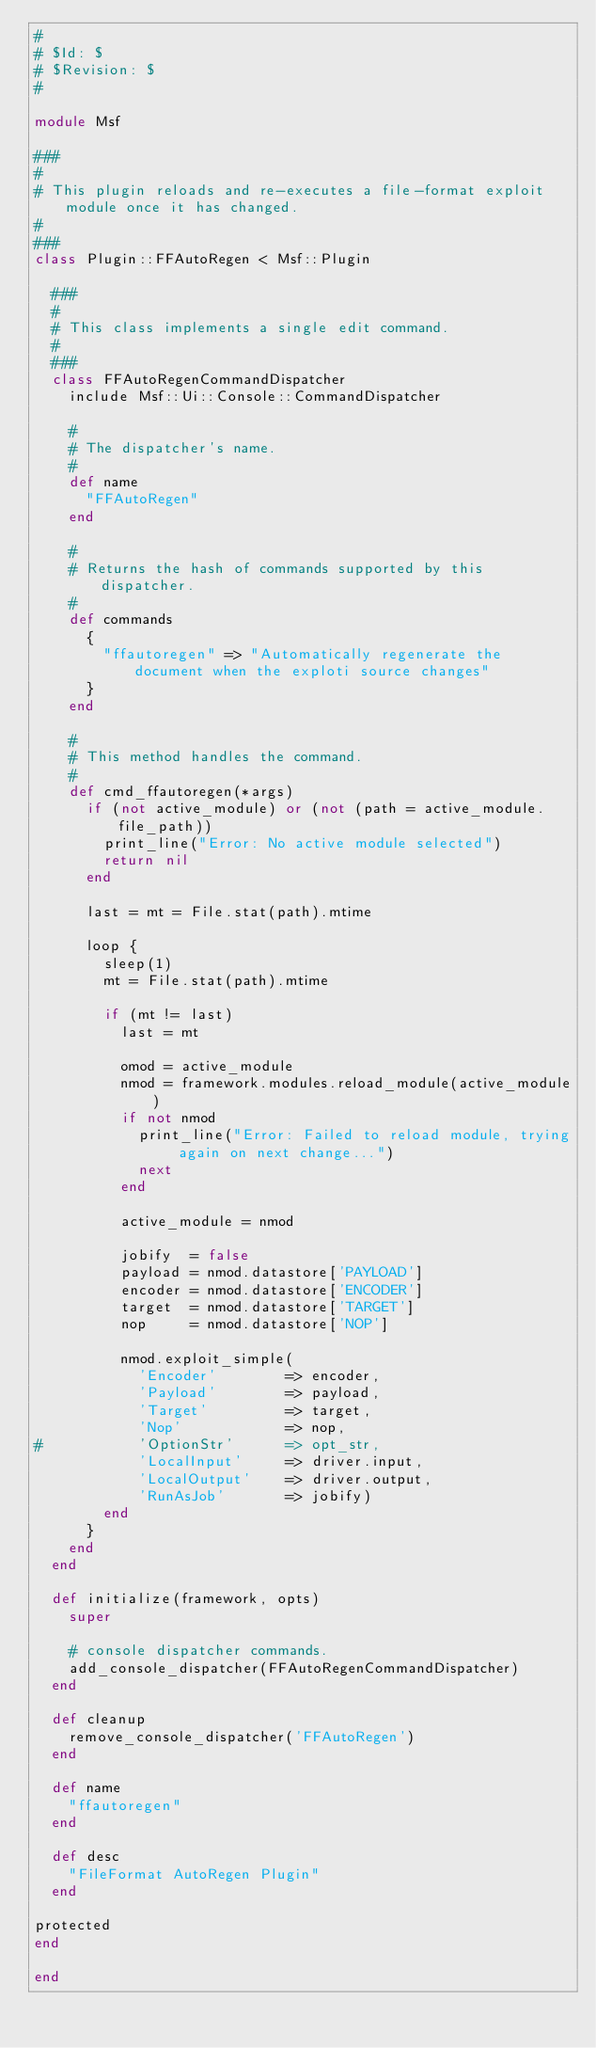Convert code to text. <code><loc_0><loc_0><loc_500><loc_500><_Ruby_>#
# $Id: $
# $Revision: $
#

module Msf

###
#
# This plugin reloads and re-executes a file-format exploit module once it has changed.
#
###
class Plugin::FFAutoRegen < Msf::Plugin

  ###
  #
  # This class implements a single edit command.
  #
  ###
  class FFAutoRegenCommandDispatcher
    include Msf::Ui::Console::CommandDispatcher

    #
    # The dispatcher's name.
    #
    def name
      "FFAutoRegen"
    end

    #
    # Returns the hash of commands supported by this dispatcher.
    #
    def commands
      {
        "ffautoregen" => "Automatically regenerate the document when the exploti source changes"
      }
    end

    #
    # This method handles the command.
    #
    def cmd_ffautoregen(*args)
      if (not active_module) or (not (path = active_module.file_path))
        print_line("Error: No active module selected")
        return nil
      end

      last = mt = File.stat(path).mtime

      loop {
        sleep(1)
        mt = File.stat(path).mtime

        if (mt != last)
          last = mt

          omod = active_module
          nmod = framework.modules.reload_module(active_module)
          if not nmod
            print_line("Error: Failed to reload module, trying again on next change...")
            next
          end

          active_module = nmod

          jobify  = false
          payload = nmod.datastore['PAYLOAD']
          encoder = nmod.datastore['ENCODER']
          target  = nmod.datastore['TARGET']
          nop     = nmod.datastore['NOP']

          nmod.exploit_simple(
            'Encoder'        => encoder,
            'Payload'        => payload,
            'Target'         => target,
            'Nop'            => nop,
#						'OptionStr'      => opt_str,
            'LocalInput'     => driver.input,
            'LocalOutput'    => driver.output,
            'RunAsJob'       => jobify)
        end
      }
    end
  end

  def initialize(framework, opts)
    super

    # console dispatcher commands.
    add_console_dispatcher(FFAutoRegenCommandDispatcher)
  end

  def cleanup
    remove_console_dispatcher('FFAutoRegen')
  end

  def name
    "ffautoregen"
  end

  def desc
    "FileFormat AutoRegen Plugin"
  end

protected
end

end
</code> 